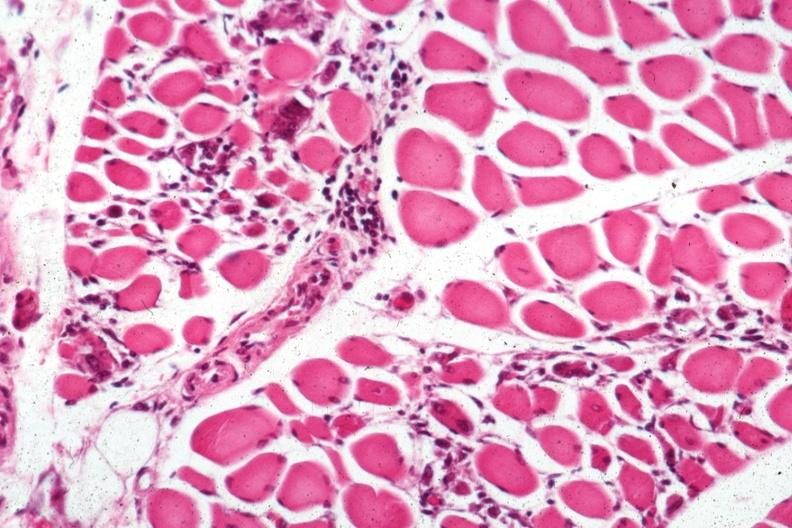what is present?
Answer the question using a single word or phrase. Soft tissue 